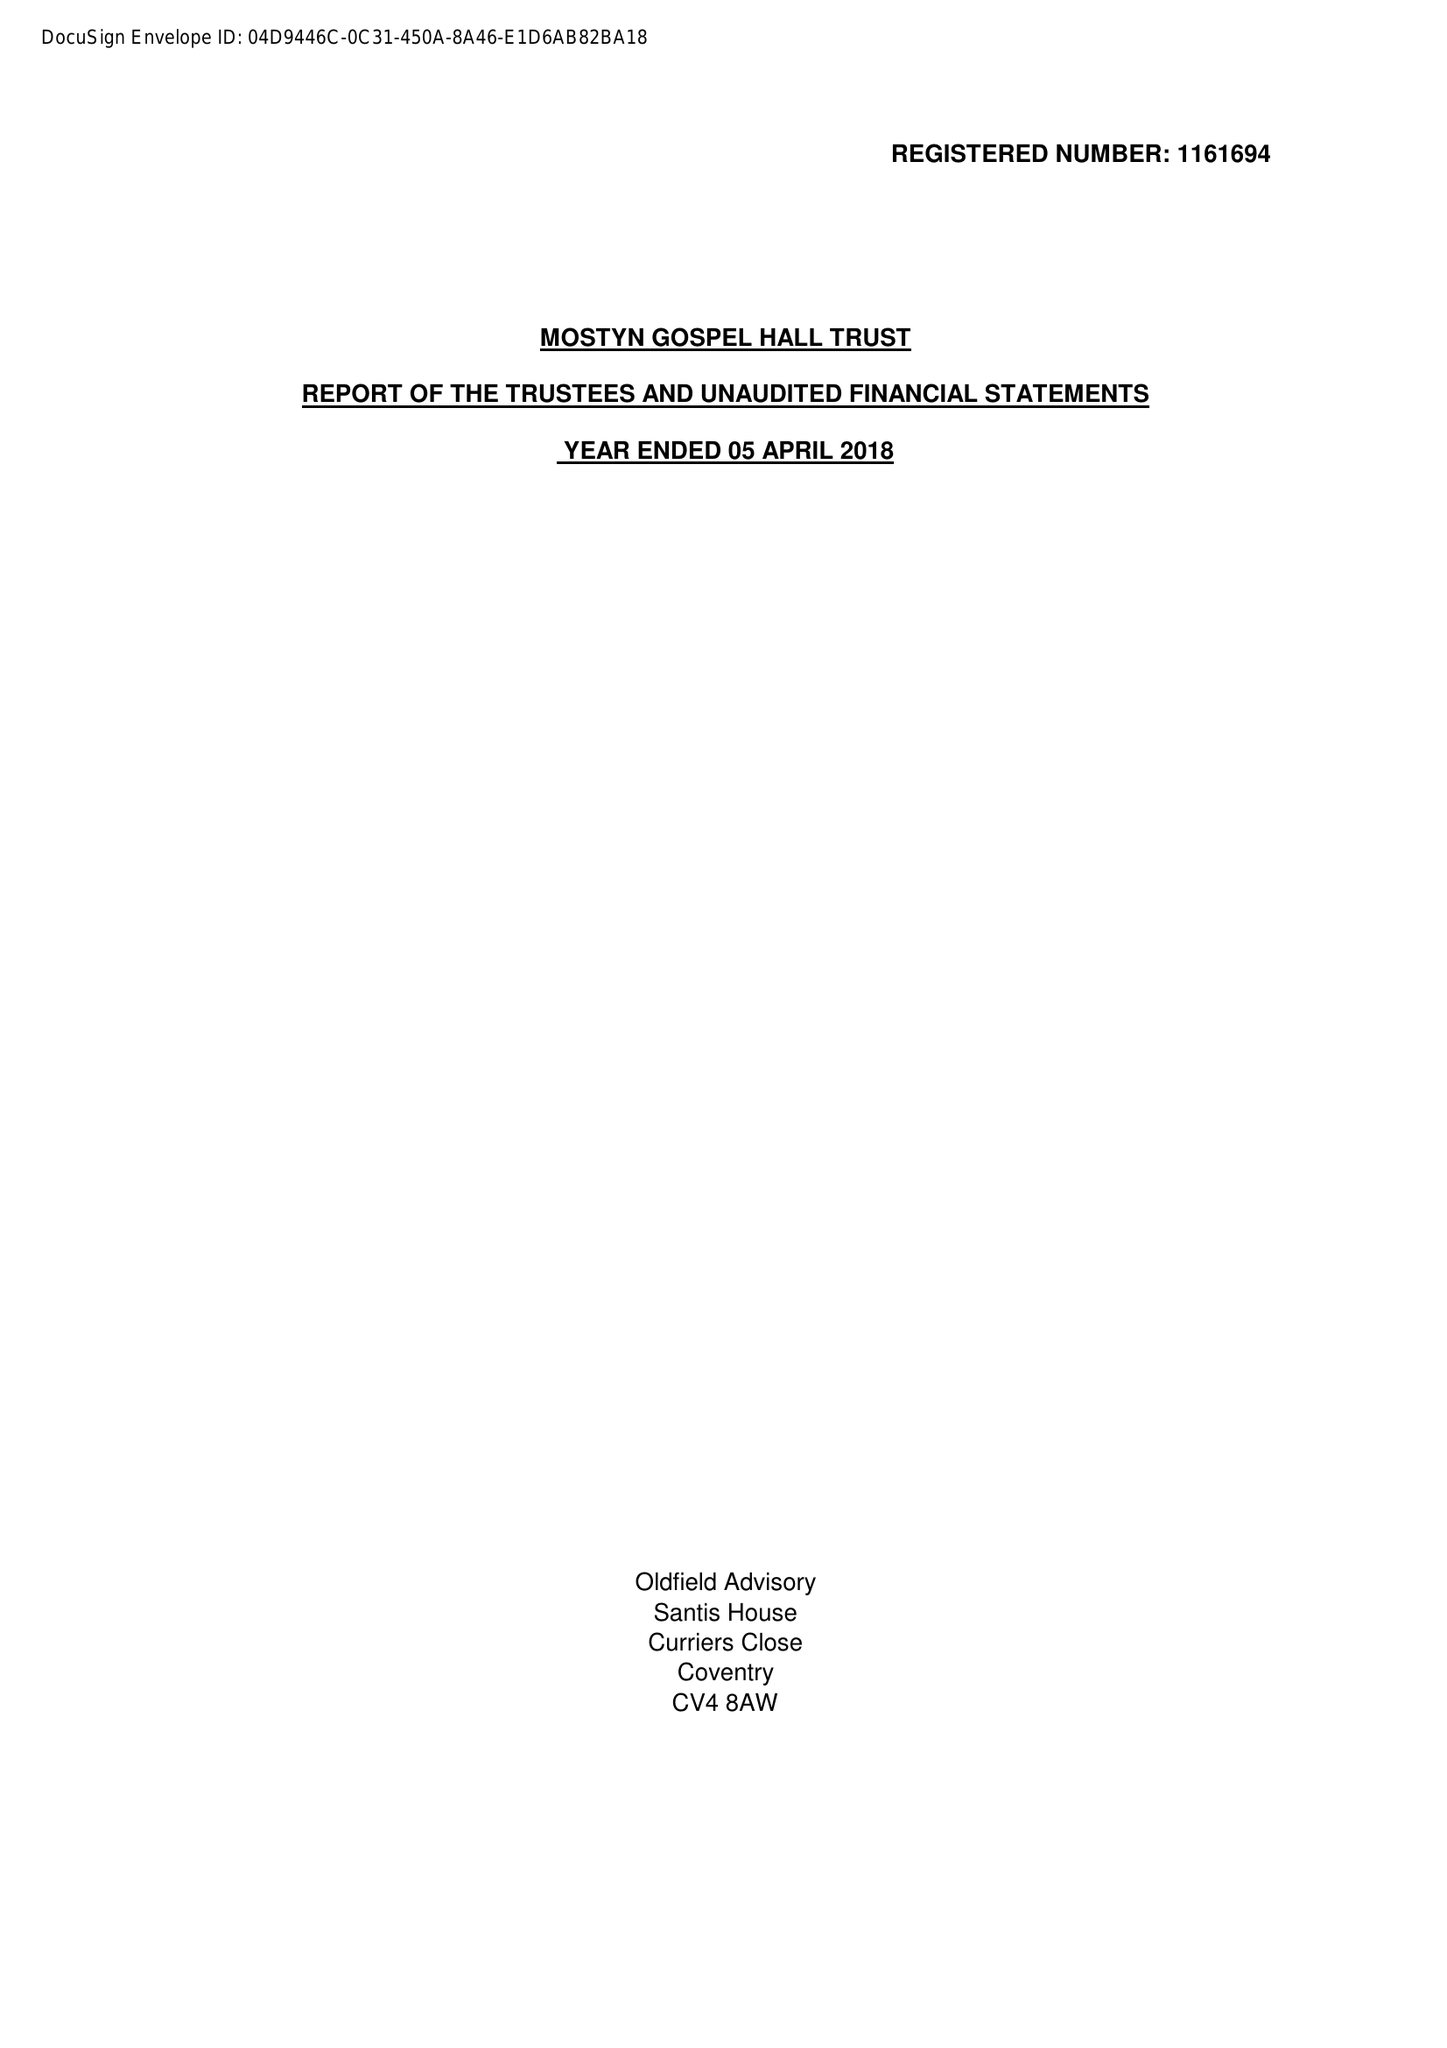What is the value for the charity_number?
Answer the question using a single word or phrase. 1161694 